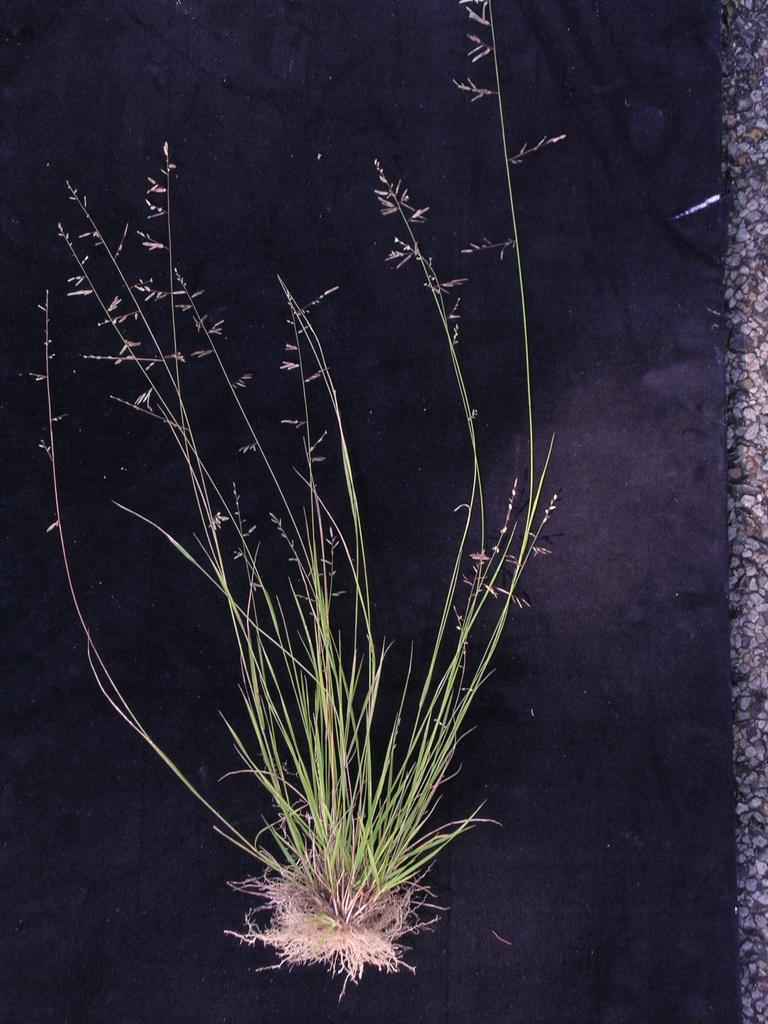What is present in the image? There is a plant in the image. Can you describe the plant's features? The plant has roots. What color is the background of the image? The background of the image is black. How much payment is required to purchase the corn in the image? There is no corn present in the image, so the question of payment is not applicable. 